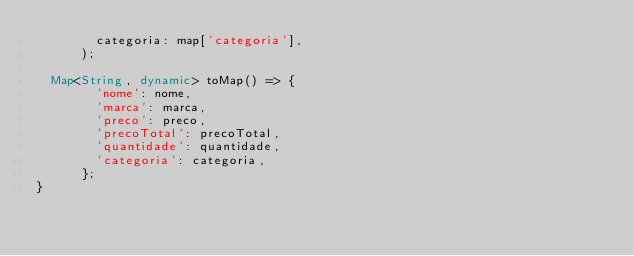<code> <loc_0><loc_0><loc_500><loc_500><_Dart_>        categoria: map['categoria'],
      );
 
  Map<String, dynamic> toMap() => {
        'nome': nome,
        'marca': marca,
        'preco': preco,
        'precoTotal': precoTotal,
        'quantidade': quantidade,
        'categoria': categoria,
      };
}</code> 